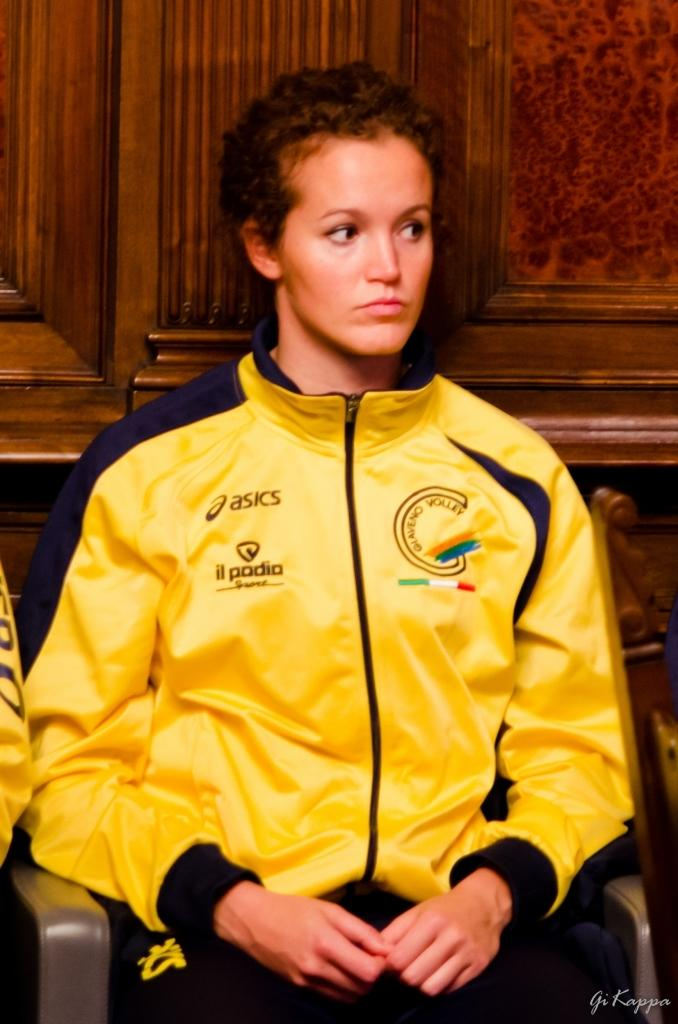<image>
Relay a brief, clear account of the picture shown. a woman wearing a yellow jersey with words Asics and Il Padia on it 